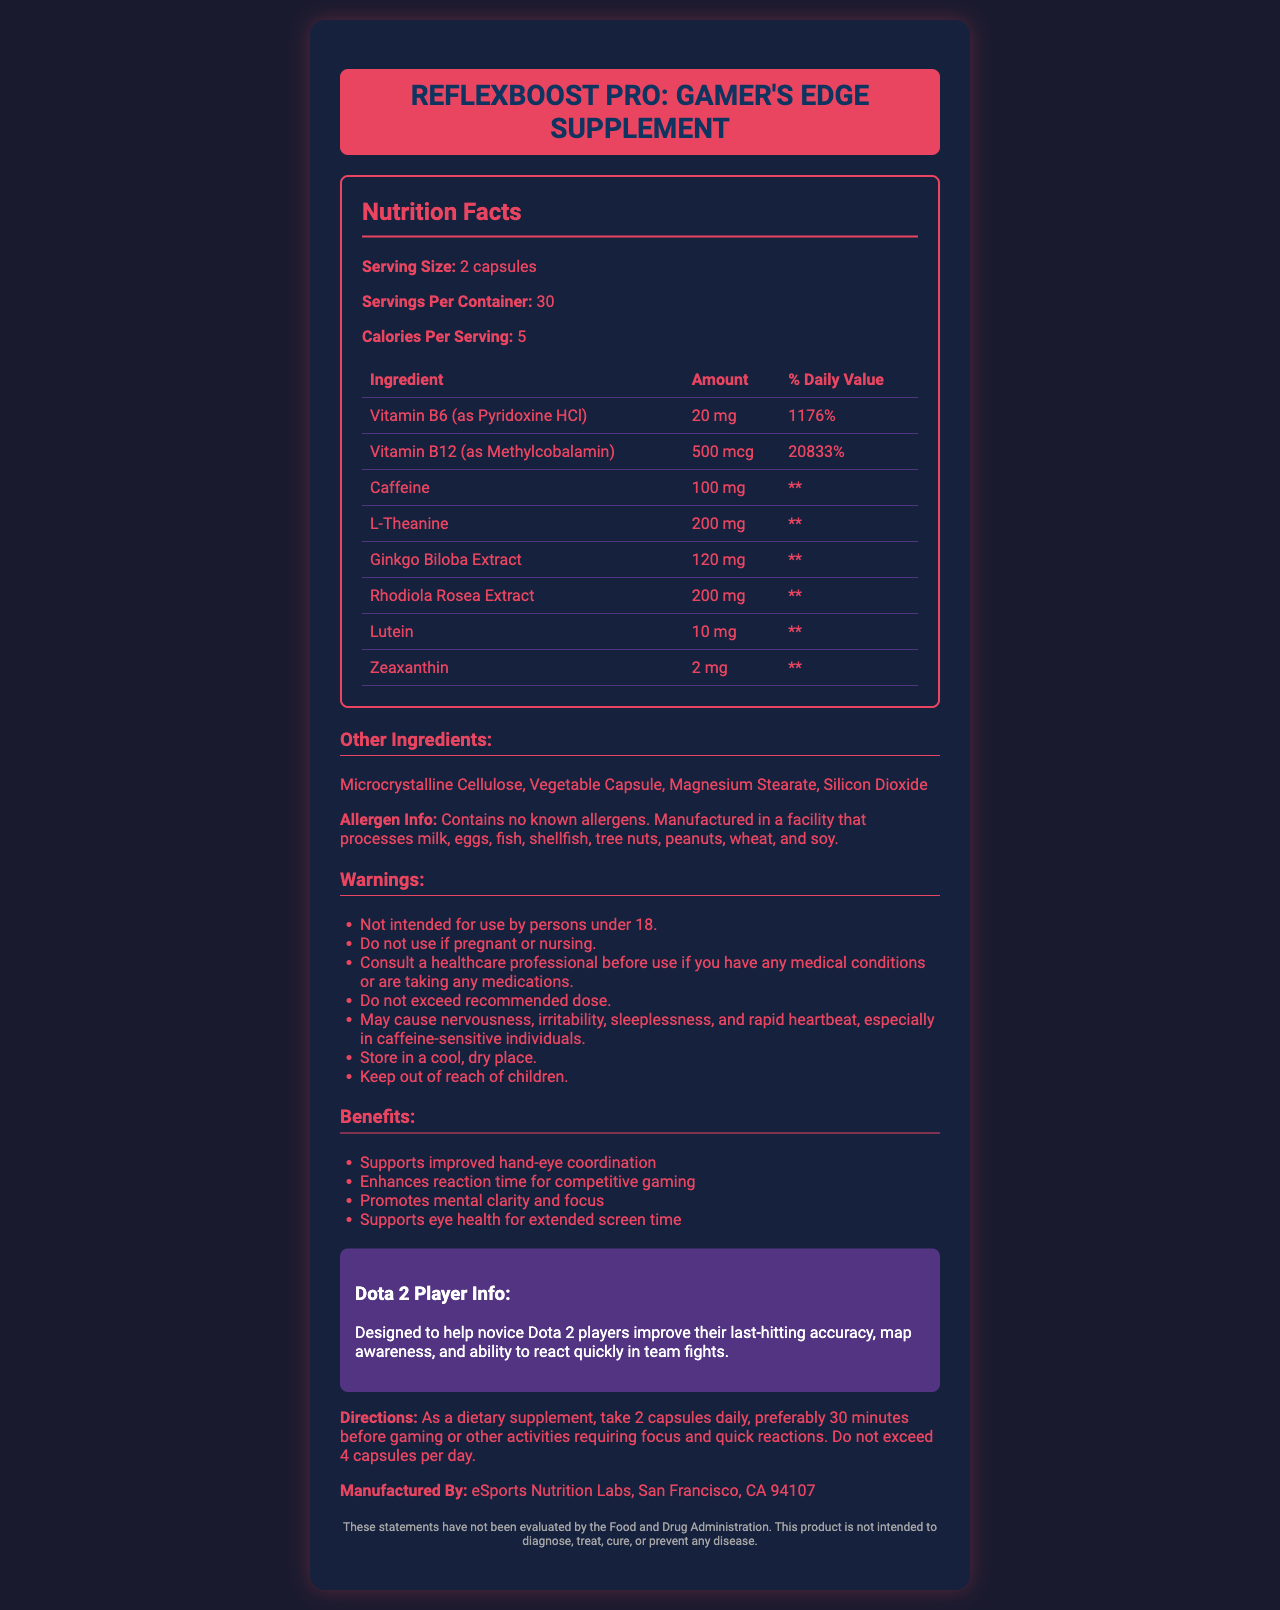what is the product name? The product name is mentioned at the top of the document where it says "ReflexBoost Pro: Gamer's Edge Supplement."
Answer: ReflexBoost Pro: Gamer's Edge Supplement what is the recommended serving size for this supplement? The serving size is stated in the Nutrition Facts section as "Serving Size: 2 capsules."
Answer: 2 capsules how many servings are there per container? The number of servings per container is listed in the Nutrition Facts section as "Servings Per Container: 30."
Answer: 30 how many calories are in each serving? The Nutrition Facts section specifies "Calories Per Serving: 5."
Answer: 5 calories when should this supplement be taken for best results? The directions state: "Take 2 capsules daily, preferably 30 minutes before gaming or other activities requiring focus and quick reactions."
Answer: 30 minutes before gaming or other activities requiring focus and quick reactions which vitamin has the highest daily value percentage? A. Vitamin B6 B. Vitamin B12 C. Vitamin C D. Vitamin D According to the document, Vitamin B12 has a daily value of 20833%, which is the highest among the listed vitamins.
Answer: B. Vitamin B12 what are the possible side effects of consuming this supplement? A. Nervousness B. Irritability C. Sleeplessness D. All of the above The warnings list includes nervousness, irritability, sleeplessness, and rapid heartbeat as potential side effects.
Answer: D. All of the above what is the primary purpose of ReflexBoost Pro? The marketing claims and Dota 2 information sections indicate that the supplement is designed to improve hand-eye coordination, reaction time, and mental clarity for competitive gaming.
Answer: To support improved hand-eye coordination and reaction time for competitive gaming are there any known allergens in this supplement? The allergen info section states "Contains no known allergens."
Answer: No is this supplement safe for children under 18? The warnings clearly state: "Not intended for use by persons under 18."
Answer: No identify two other ingredients in this supplement. The other ingredients section lists Microcrystalline Cellulose and Magnesium Stearate as part of the supplement.
Answer: Microcrystalline Cellulose, Magnesium Stearate summarize the main idea of the ReflexBoost Pro supplement. The document describes ReflexBoost Pro as a gaming supplement meant to enhance focus and reaction time, listing its ingredients, benefits, and cautions.
Answer: ReflexBoost Pro is a vitamin supplement designed for gamers to improve their hand-eye coordination, reaction time, and mental clarity, while also supporting eye health. It contains high levels of Vitamins B6 and B12, caffeine, L-Theanine, and various extracts. It is recommended to be taken 30 minutes before gaming, with precautions for certain individuals. is it safe for pregnant women to use this supplement? The warnings state "Do not use if pregnant or nursing."
Answer: No who manufactures ReflexBoost Pro? The manufacturer's information is provided at the bottom of the document: "Manufactured By: eSports Nutrition Labs, San Francisco, CA 94107."
Answer: eSports Nutrition Labs, San Francisco, CA 94107 what is the daily value percentage of Vitamin B12 in this supplement? The Nutrition Facts section lists the daily value percentage of Vitamin B12 as 20833%.
Answer: 20833% can the effect of this supplement on reaction time be scientifically verified by the provided document? The document only states marketing claims and mentions that the statements have not been evaluated by the FDA.
Answer: Not enough information 